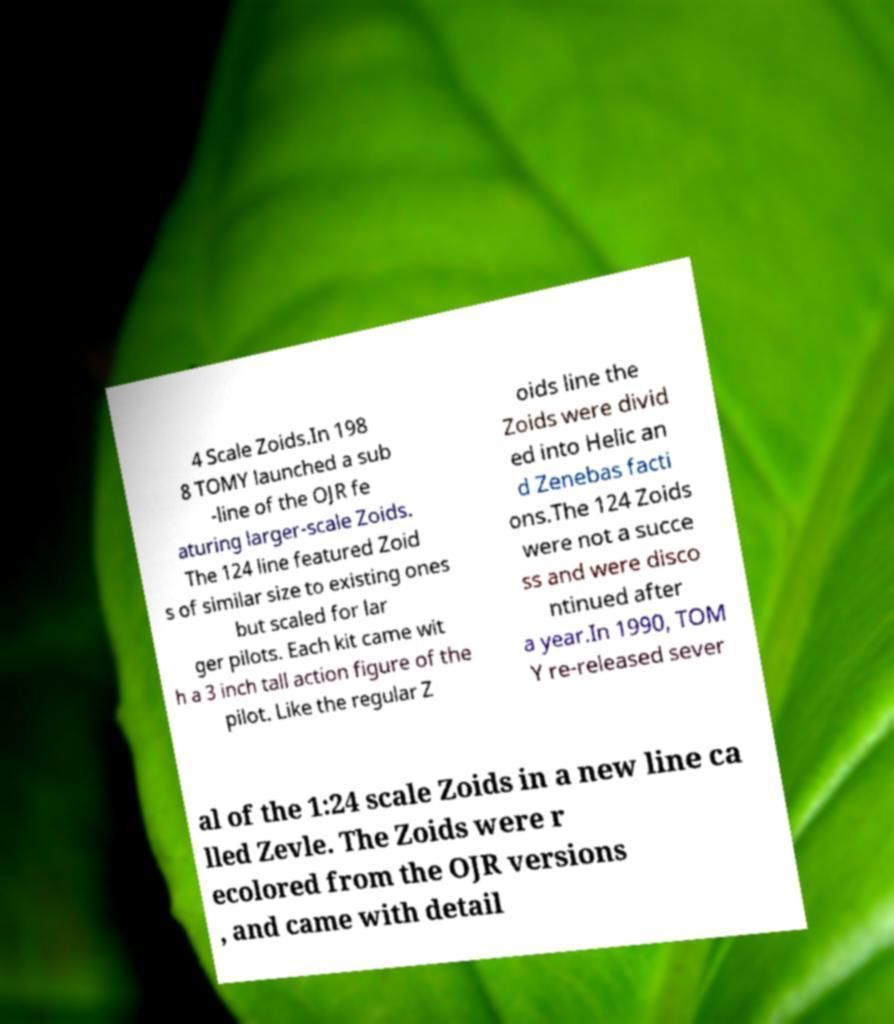Could you assist in decoding the text presented in this image and type it out clearly? 4 Scale Zoids.In 198 8 TOMY launched a sub -line of the OJR fe aturing larger-scale Zoids. The 124 line featured Zoid s of similar size to existing ones but scaled for lar ger pilots. Each kit came wit h a 3 inch tall action figure of the pilot. Like the regular Z oids line the Zoids were divid ed into Helic an d Zenebas facti ons.The 124 Zoids were not a succe ss and were disco ntinued after a year.In 1990, TOM Y re-released sever al of the 1:24 scale Zoids in a new line ca lled Zevle. The Zoids were r ecolored from the OJR versions , and came with detail 